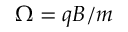Convert formula to latex. <formula><loc_0><loc_0><loc_500><loc_500>\Omega = q B / m</formula> 